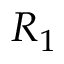<formula> <loc_0><loc_0><loc_500><loc_500>R _ { 1 }</formula> 